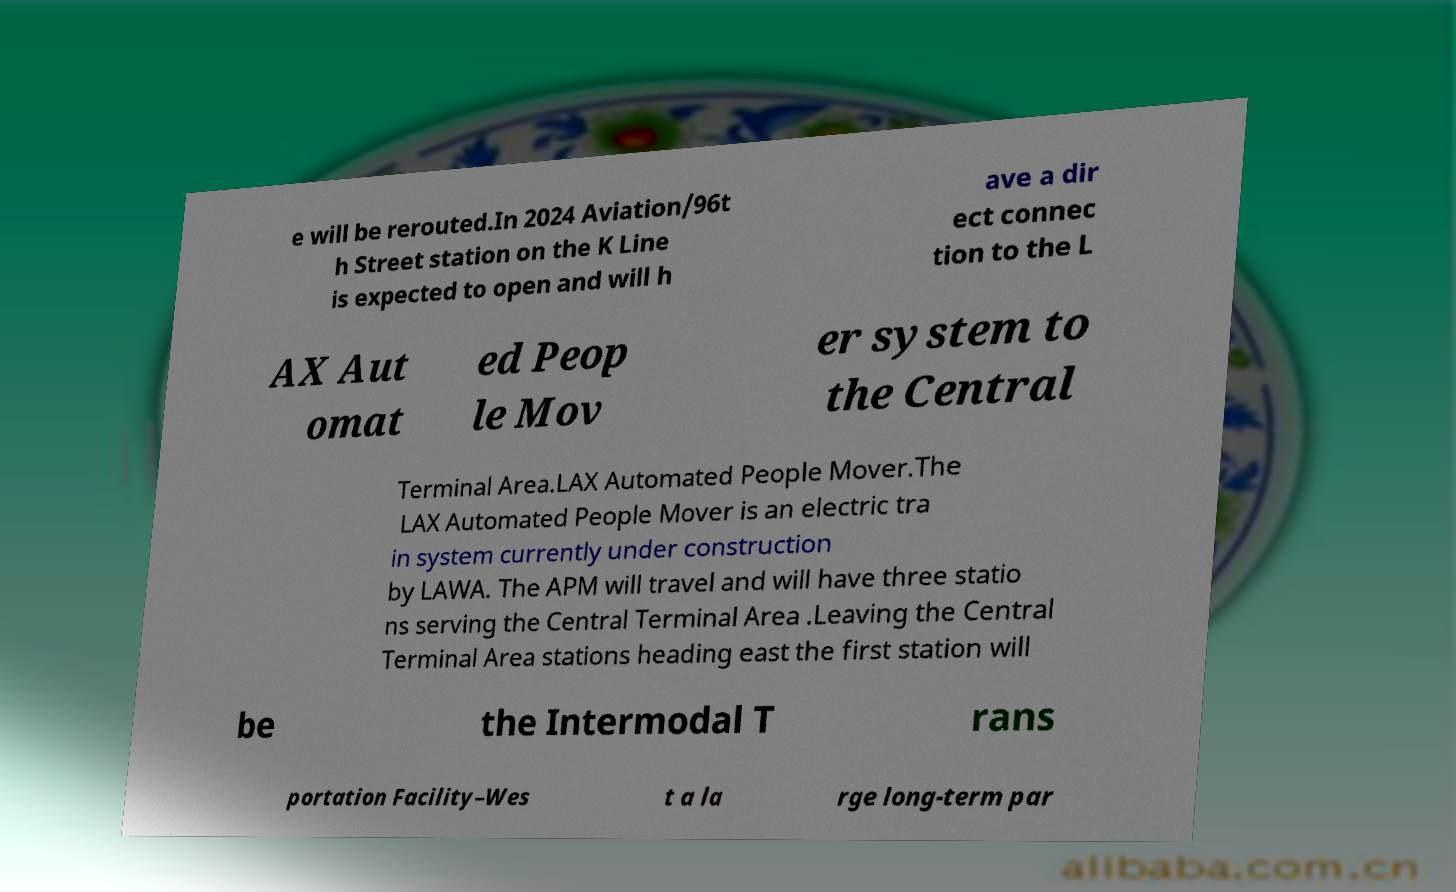What messages or text are displayed in this image? I need them in a readable, typed format. e will be rerouted.In 2024 Aviation/96t h Street station on the K Line is expected to open and will h ave a dir ect connec tion to the L AX Aut omat ed Peop le Mov er system to the Central Terminal Area.LAX Automated People Mover.The LAX Automated People Mover is an electric tra in system currently under construction by LAWA. The APM will travel and will have three statio ns serving the Central Terminal Area .Leaving the Central Terminal Area stations heading east the first station will be the Intermodal T rans portation Facility–Wes t a la rge long-term par 